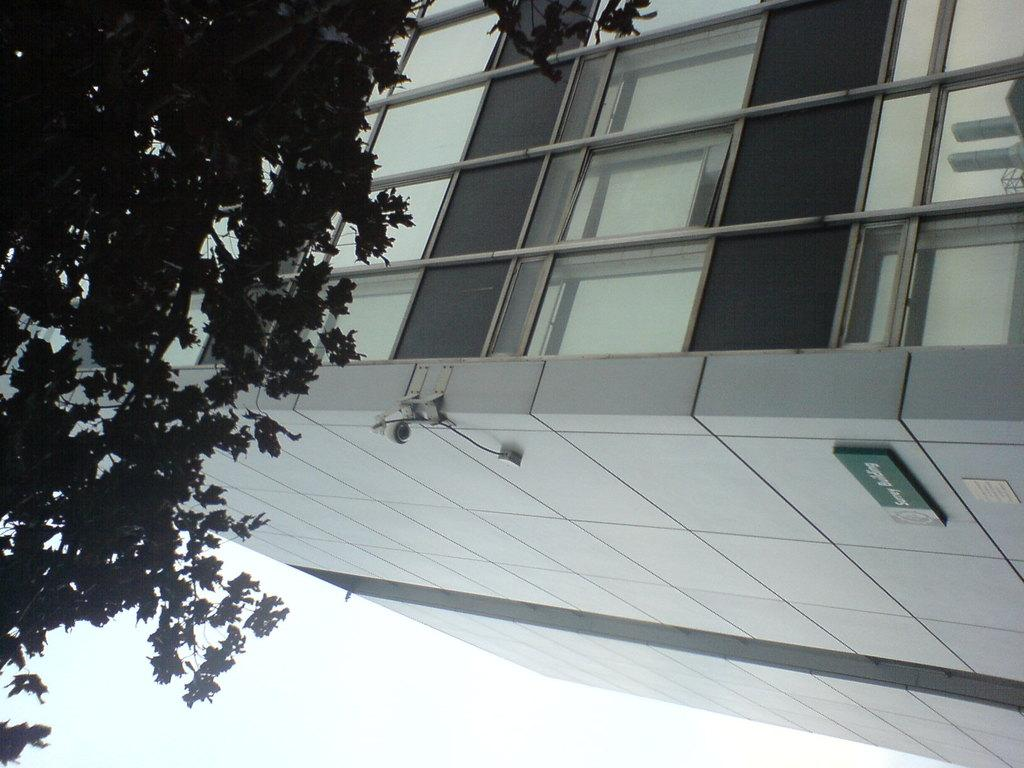What type of structure is present in the image? There is a building in the image. What object can be seen near the building? There is a board in the image. What type of vegetation is visible in the image? There are trees in the image. What is visible above the building and trees? The sky is visible in the image. What type of celery is being used to drive the building in the image? There is no celery or driving present in the image; it features a building, a board, trees, and the sky. 